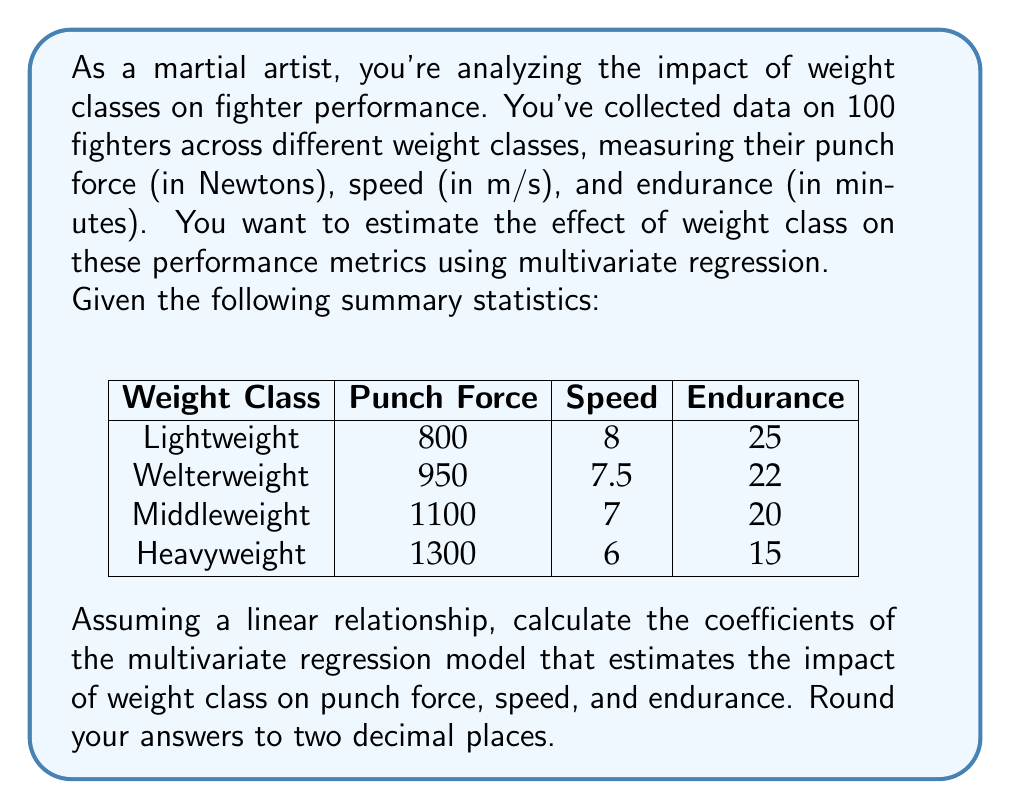Can you solve this math problem? To solve this problem, we'll use the multivariate regression model:

$$Y = XB + E$$

Where:
- $Y$ is the matrix of dependent variables (punch force, speed, endurance)
- $X$ is the matrix of independent variables (weight class, coded as 1, 2, 3, 4)
- $B$ is the matrix of coefficients we want to estimate
- $E$ is the error term

Step 1: Set up the matrices

$$X = \begin{bmatrix}
1 & 1 \\
1 & 2 \\
1 & 3 \\
1 & 4
\end{bmatrix}$$

$$Y = \begin{bmatrix}
800 & 8 & 25 \\
950 & 7.5 & 22 \\
1100 & 7 & 20 \\
1300 & 6 & 15
\end{bmatrix}$$

Step 2: Calculate $B$ using the formula:

$$B = (X^TX)^{-1}X^TY$$

Step 3: Calculate $X^TX$

$$X^TX = \begin{bmatrix}
4 & 10 \\
10 & 30
\end{bmatrix}$$

Step 4: Calculate $(X^TX)^{-1}$

$$(X^TX)^{-1} = \frac{1}{20}\begin{bmatrix}
30 & -10 \\
-10 & 4
\end{bmatrix}$$

Step 5: Calculate $X^TY$

$$X^TY = \begin{bmatrix}
4150 & 28.5 & 82 \\
13750 & 83 & 229
\end{bmatrix}$$

Step 6: Multiply $(X^TX)^{-1}$ and $X^TY$

$$B = \frac{1}{20}\begin{bmatrix}
30 & -10 \\
-10 & 4
\end{bmatrix} \times \begin{bmatrix}
4150 & 28.5 & 82 \\
13750 & 83 & 229
\end{bmatrix}$$

$$B = \begin{bmatrix}
575 & 9.25 & 31 \\
165 & -0.65 & -3.3
\end{bmatrix}$$

The first row represents the intercepts, and the second row represents the slopes (coefficients) for each dependent variable.
Answer: Coefficients: Punch Force: 165.00, Speed: -0.65, Endurance: -3.30 